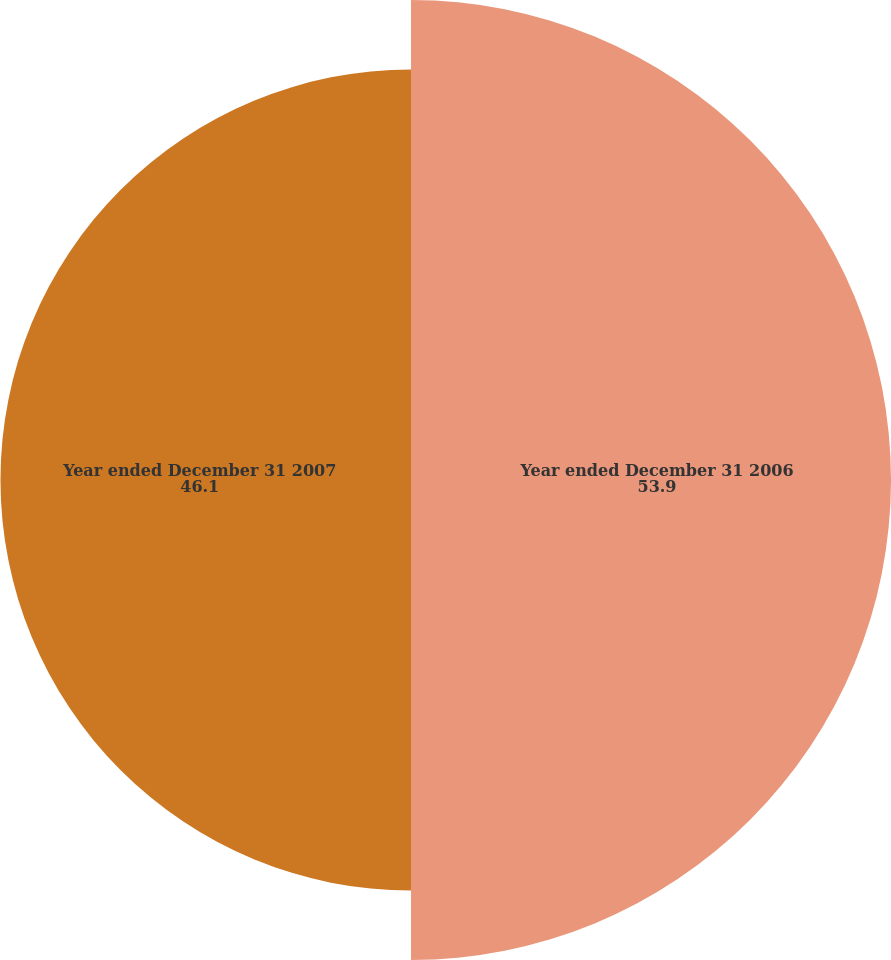Convert chart to OTSL. <chart><loc_0><loc_0><loc_500><loc_500><pie_chart><fcel>Year ended December 31 2006<fcel>Year ended December 31 2007<nl><fcel>53.9%<fcel>46.1%<nl></chart> 